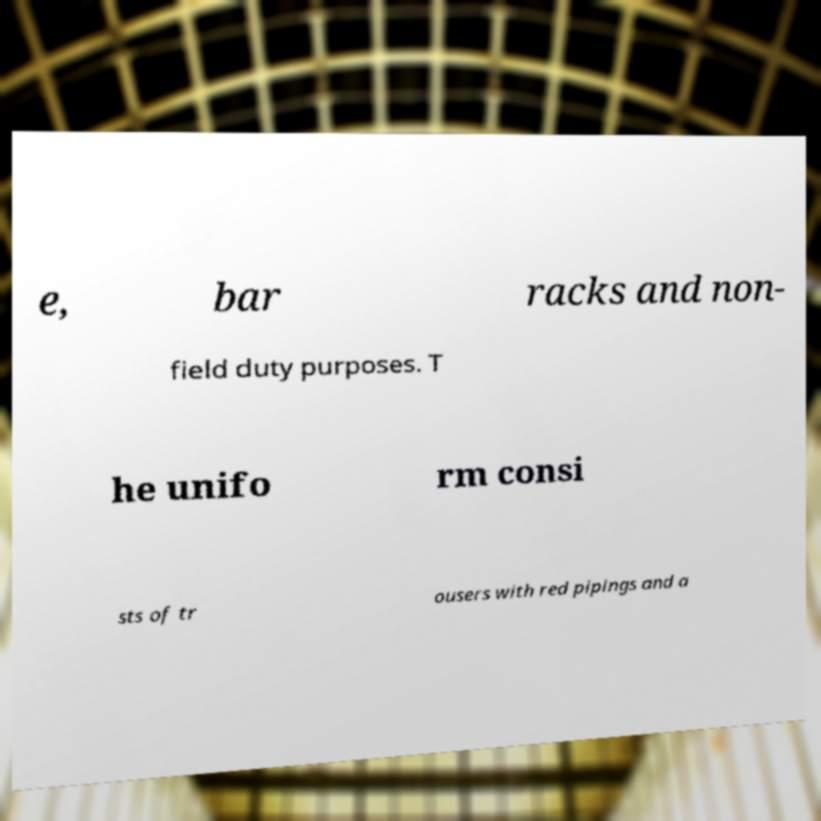Can you accurately transcribe the text from the provided image for me? e, bar racks and non- field duty purposes. T he unifo rm consi sts of tr ousers with red pipings and a 